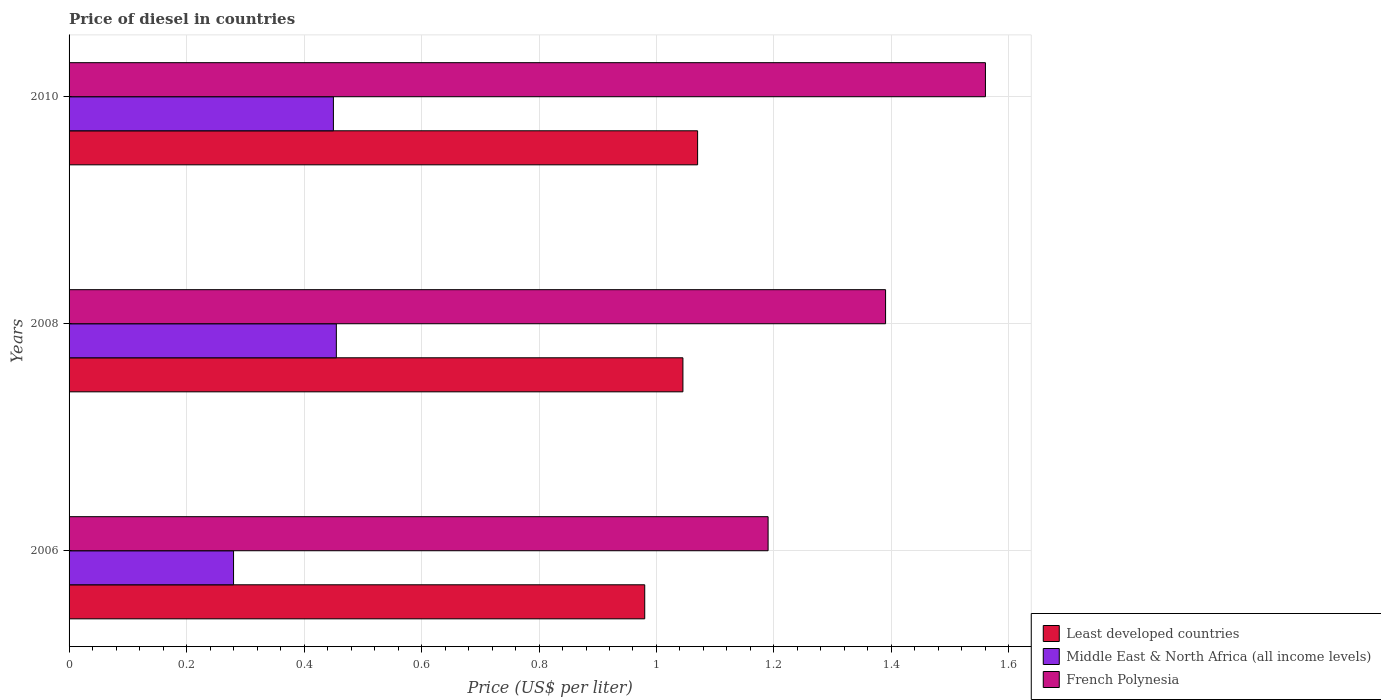Are the number of bars per tick equal to the number of legend labels?
Ensure brevity in your answer.  Yes. How many bars are there on the 2nd tick from the top?
Give a very brief answer. 3. In how many cases, is the number of bars for a given year not equal to the number of legend labels?
Provide a succinct answer. 0. What is the price of diesel in Middle East & North Africa (all income levels) in 2006?
Ensure brevity in your answer.  0.28. Across all years, what is the maximum price of diesel in French Polynesia?
Your response must be concise. 1.56. Across all years, what is the minimum price of diesel in Middle East & North Africa (all income levels)?
Your response must be concise. 0.28. In which year was the price of diesel in French Polynesia maximum?
Your answer should be very brief. 2010. In which year was the price of diesel in French Polynesia minimum?
Make the answer very short. 2006. What is the total price of diesel in Least developed countries in the graph?
Your answer should be very brief. 3.09. What is the difference between the price of diesel in Least developed countries in 2008 and that in 2010?
Keep it short and to the point. -0.03. What is the difference between the price of diesel in Least developed countries in 2010 and the price of diesel in French Polynesia in 2008?
Keep it short and to the point. -0.32. What is the average price of diesel in French Polynesia per year?
Provide a short and direct response. 1.38. In the year 2006, what is the difference between the price of diesel in Middle East & North Africa (all income levels) and price of diesel in French Polynesia?
Your response must be concise. -0.91. What is the ratio of the price of diesel in Middle East & North Africa (all income levels) in 2006 to that in 2010?
Ensure brevity in your answer.  0.62. Is the difference between the price of diesel in Middle East & North Africa (all income levels) in 2006 and 2008 greater than the difference between the price of diesel in French Polynesia in 2006 and 2008?
Give a very brief answer. Yes. What is the difference between the highest and the second highest price of diesel in French Polynesia?
Your answer should be very brief. 0.17. What is the difference between the highest and the lowest price of diesel in Least developed countries?
Offer a very short reply. 0.09. What does the 2nd bar from the top in 2008 represents?
Your answer should be very brief. Middle East & North Africa (all income levels). What does the 1st bar from the bottom in 2006 represents?
Give a very brief answer. Least developed countries. How many legend labels are there?
Keep it short and to the point. 3. What is the title of the graph?
Ensure brevity in your answer.  Price of diesel in countries. Does "Rwanda" appear as one of the legend labels in the graph?
Your response must be concise. No. What is the label or title of the X-axis?
Offer a terse response. Price (US$ per liter). What is the label or title of the Y-axis?
Make the answer very short. Years. What is the Price (US$ per liter) of Middle East & North Africa (all income levels) in 2006?
Keep it short and to the point. 0.28. What is the Price (US$ per liter) in French Polynesia in 2006?
Give a very brief answer. 1.19. What is the Price (US$ per liter) in Least developed countries in 2008?
Ensure brevity in your answer.  1.04. What is the Price (US$ per liter) of Middle East & North Africa (all income levels) in 2008?
Give a very brief answer. 0.46. What is the Price (US$ per liter) in French Polynesia in 2008?
Offer a very short reply. 1.39. What is the Price (US$ per liter) of Least developed countries in 2010?
Provide a succinct answer. 1.07. What is the Price (US$ per liter) of Middle East & North Africa (all income levels) in 2010?
Provide a short and direct response. 0.45. What is the Price (US$ per liter) of French Polynesia in 2010?
Make the answer very short. 1.56. Across all years, what is the maximum Price (US$ per liter) in Least developed countries?
Your answer should be compact. 1.07. Across all years, what is the maximum Price (US$ per liter) in Middle East & North Africa (all income levels)?
Give a very brief answer. 0.46. Across all years, what is the maximum Price (US$ per liter) in French Polynesia?
Your answer should be compact. 1.56. Across all years, what is the minimum Price (US$ per liter) of Middle East & North Africa (all income levels)?
Offer a terse response. 0.28. Across all years, what is the minimum Price (US$ per liter) of French Polynesia?
Provide a short and direct response. 1.19. What is the total Price (US$ per liter) in Least developed countries in the graph?
Offer a very short reply. 3.1. What is the total Price (US$ per liter) in Middle East & North Africa (all income levels) in the graph?
Make the answer very short. 1.19. What is the total Price (US$ per liter) of French Polynesia in the graph?
Make the answer very short. 4.14. What is the difference between the Price (US$ per liter) in Least developed countries in 2006 and that in 2008?
Provide a short and direct response. -0.07. What is the difference between the Price (US$ per liter) in Middle East & North Africa (all income levels) in 2006 and that in 2008?
Ensure brevity in your answer.  -0.17. What is the difference between the Price (US$ per liter) of French Polynesia in 2006 and that in 2008?
Offer a terse response. -0.2. What is the difference between the Price (US$ per liter) of Least developed countries in 2006 and that in 2010?
Provide a short and direct response. -0.09. What is the difference between the Price (US$ per liter) in Middle East & North Africa (all income levels) in 2006 and that in 2010?
Provide a short and direct response. -0.17. What is the difference between the Price (US$ per liter) of French Polynesia in 2006 and that in 2010?
Your answer should be compact. -0.37. What is the difference between the Price (US$ per liter) of Least developed countries in 2008 and that in 2010?
Offer a very short reply. -0.03. What is the difference between the Price (US$ per liter) of Middle East & North Africa (all income levels) in 2008 and that in 2010?
Your answer should be compact. 0.01. What is the difference between the Price (US$ per liter) in French Polynesia in 2008 and that in 2010?
Your answer should be very brief. -0.17. What is the difference between the Price (US$ per liter) in Least developed countries in 2006 and the Price (US$ per liter) in Middle East & North Africa (all income levels) in 2008?
Your answer should be compact. 0.53. What is the difference between the Price (US$ per liter) in Least developed countries in 2006 and the Price (US$ per liter) in French Polynesia in 2008?
Make the answer very short. -0.41. What is the difference between the Price (US$ per liter) in Middle East & North Africa (all income levels) in 2006 and the Price (US$ per liter) in French Polynesia in 2008?
Your answer should be compact. -1.11. What is the difference between the Price (US$ per liter) in Least developed countries in 2006 and the Price (US$ per liter) in Middle East & North Africa (all income levels) in 2010?
Provide a succinct answer. 0.53. What is the difference between the Price (US$ per liter) of Least developed countries in 2006 and the Price (US$ per liter) of French Polynesia in 2010?
Provide a succinct answer. -0.58. What is the difference between the Price (US$ per liter) in Middle East & North Africa (all income levels) in 2006 and the Price (US$ per liter) in French Polynesia in 2010?
Provide a short and direct response. -1.28. What is the difference between the Price (US$ per liter) of Least developed countries in 2008 and the Price (US$ per liter) of Middle East & North Africa (all income levels) in 2010?
Your response must be concise. 0.59. What is the difference between the Price (US$ per liter) in Least developed countries in 2008 and the Price (US$ per liter) in French Polynesia in 2010?
Your answer should be compact. -0.52. What is the difference between the Price (US$ per liter) of Middle East & North Africa (all income levels) in 2008 and the Price (US$ per liter) of French Polynesia in 2010?
Give a very brief answer. -1.1. What is the average Price (US$ per liter) in Least developed countries per year?
Ensure brevity in your answer.  1.03. What is the average Price (US$ per liter) in Middle East & North Africa (all income levels) per year?
Ensure brevity in your answer.  0.4. What is the average Price (US$ per liter) in French Polynesia per year?
Your answer should be compact. 1.38. In the year 2006, what is the difference between the Price (US$ per liter) of Least developed countries and Price (US$ per liter) of French Polynesia?
Your response must be concise. -0.21. In the year 2006, what is the difference between the Price (US$ per liter) of Middle East & North Africa (all income levels) and Price (US$ per liter) of French Polynesia?
Your answer should be very brief. -0.91. In the year 2008, what is the difference between the Price (US$ per liter) of Least developed countries and Price (US$ per liter) of Middle East & North Africa (all income levels)?
Your answer should be compact. 0.59. In the year 2008, what is the difference between the Price (US$ per liter) in Least developed countries and Price (US$ per liter) in French Polynesia?
Your response must be concise. -0.34. In the year 2008, what is the difference between the Price (US$ per liter) in Middle East & North Africa (all income levels) and Price (US$ per liter) in French Polynesia?
Give a very brief answer. -0.94. In the year 2010, what is the difference between the Price (US$ per liter) in Least developed countries and Price (US$ per liter) in Middle East & North Africa (all income levels)?
Give a very brief answer. 0.62. In the year 2010, what is the difference between the Price (US$ per liter) of Least developed countries and Price (US$ per liter) of French Polynesia?
Give a very brief answer. -0.49. In the year 2010, what is the difference between the Price (US$ per liter) of Middle East & North Africa (all income levels) and Price (US$ per liter) of French Polynesia?
Provide a succinct answer. -1.11. What is the ratio of the Price (US$ per liter) in Least developed countries in 2006 to that in 2008?
Your answer should be very brief. 0.94. What is the ratio of the Price (US$ per liter) of Middle East & North Africa (all income levels) in 2006 to that in 2008?
Make the answer very short. 0.62. What is the ratio of the Price (US$ per liter) in French Polynesia in 2006 to that in 2008?
Keep it short and to the point. 0.86. What is the ratio of the Price (US$ per liter) of Least developed countries in 2006 to that in 2010?
Your answer should be compact. 0.92. What is the ratio of the Price (US$ per liter) in Middle East & North Africa (all income levels) in 2006 to that in 2010?
Give a very brief answer. 0.62. What is the ratio of the Price (US$ per liter) of French Polynesia in 2006 to that in 2010?
Make the answer very short. 0.76. What is the ratio of the Price (US$ per liter) of Least developed countries in 2008 to that in 2010?
Give a very brief answer. 0.98. What is the ratio of the Price (US$ per liter) in Middle East & North Africa (all income levels) in 2008 to that in 2010?
Your answer should be very brief. 1.01. What is the ratio of the Price (US$ per liter) of French Polynesia in 2008 to that in 2010?
Offer a very short reply. 0.89. What is the difference between the highest and the second highest Price (US$ per liter) of Least developed countries?
Your answer should be very brief. 0.03. What is the difference between the highest and the second highest Price (US$ per liter) in Middle East & North Africa (all income levels)?
Your answer should be very brief. 0.01. What is the difference between the highest and the second highest Price (US$ per liter) of French Polynesia?
Keep it short and to the point. 0.17. What is the difference between the highest and the lowest Price (US$ per liter) in Least developed countries?
Your response must be concise. 0.09. What is the difference between the highest and the lowest Price (US$ per liter) in Middle East & North Africa (all income levels)?
Offer a terse response. 0.17. What is the difference between the highest and the lowest Price (US$ per liter) of French Polynesia?
Your response must be concise. 0.37. 